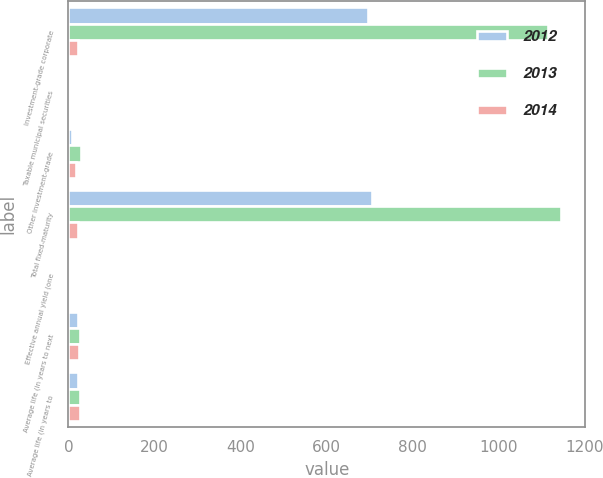Convert chart to OTSL. <chart><loc_0><loc_0><loc_500><loc_500><stacked_bar_chart><ecel><fcel>Investment-grade corporate<fcel>Taxable municipal securities<fcel>Other investment-grade<fcel>Total fixed-maturity<fcel>Effective annual yield (one<fcel>Average life (in years to next<fcel>Average life (in years to<nl><fcel>2012<fcel>696.3<fcel>0<fcel>8.7<fcel>705<fcel>4.77<fcel>22.9<fcel>23.4<nl><fcel>2013<fcel>1113.2<fcel>0<fcel>30.6<fcel>1143.8<fcel>4.65<fcel>26<fcel>26.5<nl><fcel>2014<fcel>23.4<fcel>1.5<fcel>16.9<fcel>23.4<fcel>4.3<fcel>25.6<fcel>26.7<nl></chart> 